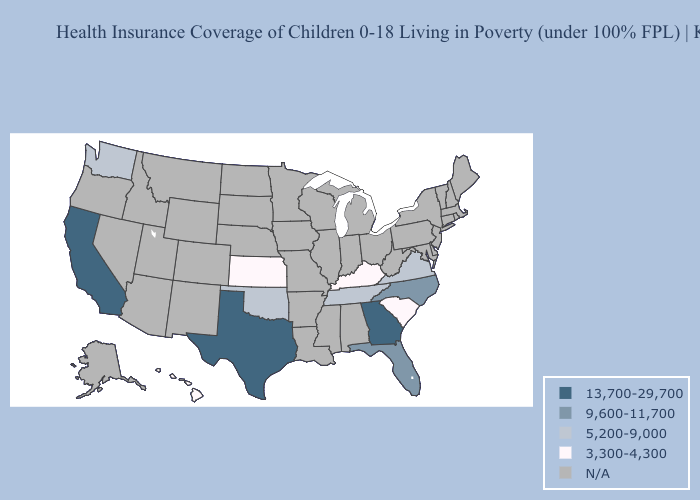What is the value of Wisconsin?
Write a very short answer. N/A. What is the lowest value in states that border Alabama?
Give a very brief answer. 5,200-9,000. Name the states that have a value in the range 5,200-9,000?
Answer briefly. Oklahoma, Tennessee, Virginia, Washington. Which states have the lowest value in the USA?
Quick response, please. Hawaii, Kansas, Kentucky, South Carolina. Name the states that have a value in the range 5,200-9,000?
Write a very short answer. Oklahoma, Tennessee, Virginia, Washington. What is the value of Arkansas?
Keep it brief. N/A. Does California have the highest value in the West?
Quick response, please. Yes. Among the states that border West Virginia , which have the lowest value?
Write a very short answer. Kentucky. What is the value of New Mexico?
Be succinct. N/A. What is the value of Nevada?
Concise answer only. N/A. What is the value of Nebraska?
Concise answer only. N/A. What is the value of Florida?
Short answer required. 9,600-11,700. 